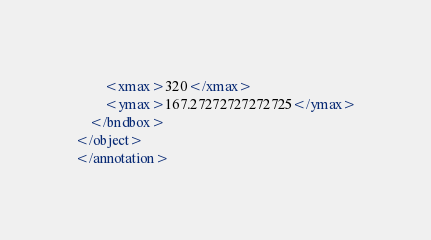Convert code to text. <code><loc_0><loc_0><loc_500><loc_500><_XML_>        <xmax>320</xmax>
        <ymax>167.27272727272725</ymax>
    </bndbox>
</object>
</annotation>
</code> 